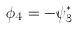<formula> <loc_0><loc_0><loc_500><loc_500>\phi _ { 4 } = - \psi _ { 3 } ^ { * }</formula> 